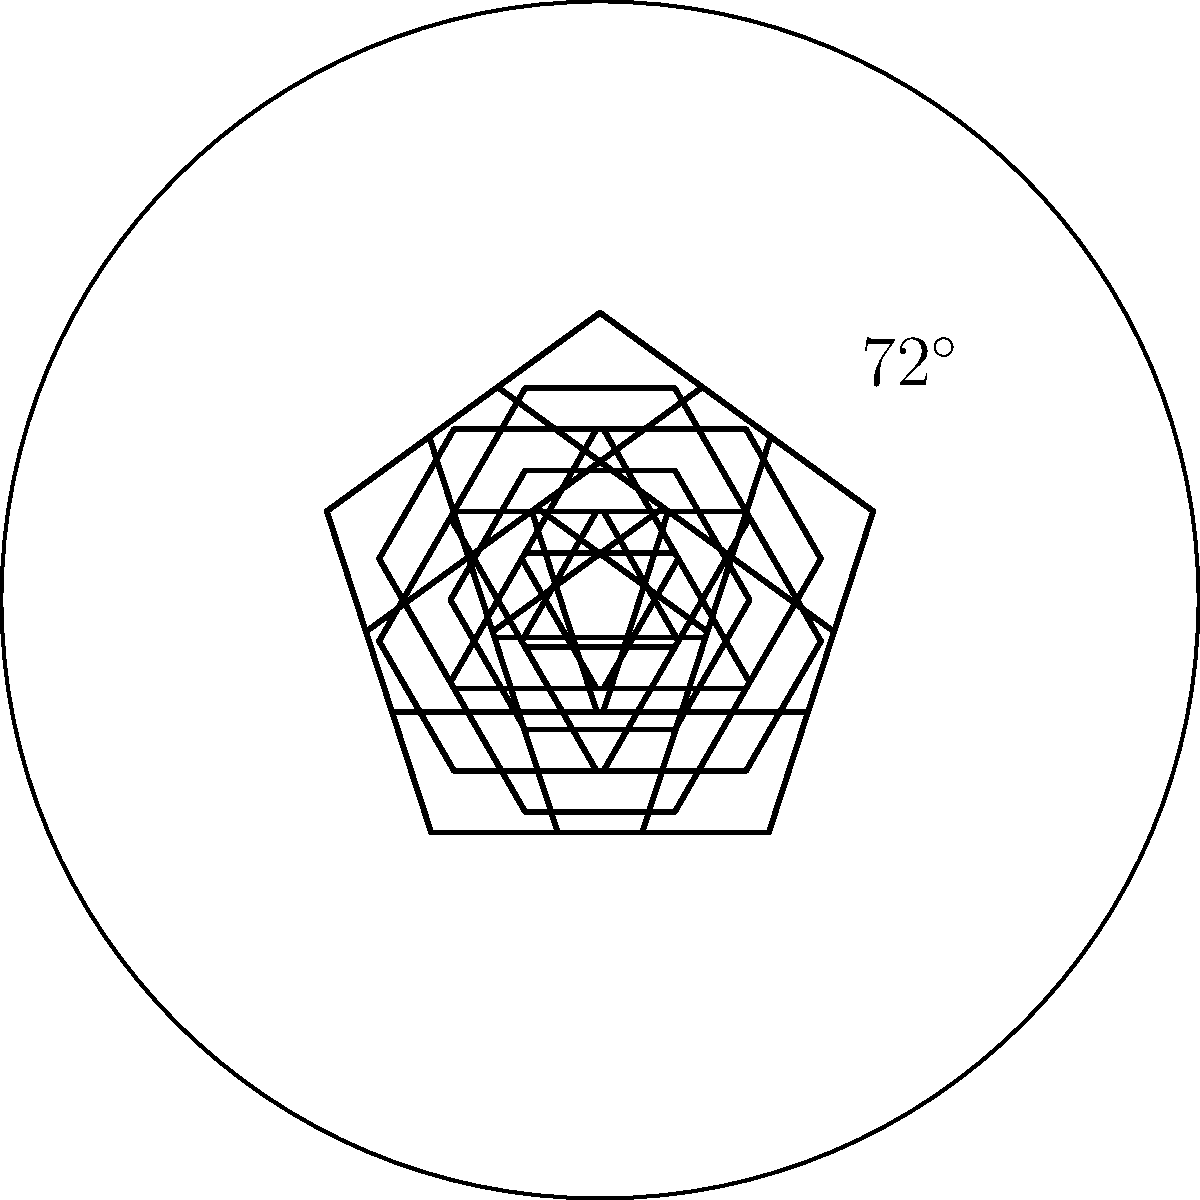In the design of a typical soccer ball, pentagons and hexagons are arranged in a specific pattern. What is the order of rotational symmetry for the pentagonal sections in this soccer ball design? To determine the order of rotational symmetry for the pentagonal sections, we need to follow these steps:

1. Observe the arrangement of pentagons in the soccer ball design.
2. Count the number of pentagon sections visible in the diagram.
3. Determine the angle of rotation between each pentagon.
4. Calculate the order of rotational symmetry.

Step 1: The diagram shows a top view of a soccer ball with pentagonal and hexagonal sections.

Step 2: We can see 5 pentagonal sections arranged around the center of the ball.

Step 3: The angle between each pentagon is marked as $72^\circ$. This can be calculated by dividing 360° by the number of pentagons: $360^\circ \div 5 = 72^\circ$.

Step 4: The order of rotational symmetry is the number of times the pattern repeats in a full 360° rotation. In this case, it's equal to the number of pentagonal sections, which is 5.

Therefore, the order of rotational symmetry for the pentagonal sections in this soccer ball design is 5.
Answer: 5 